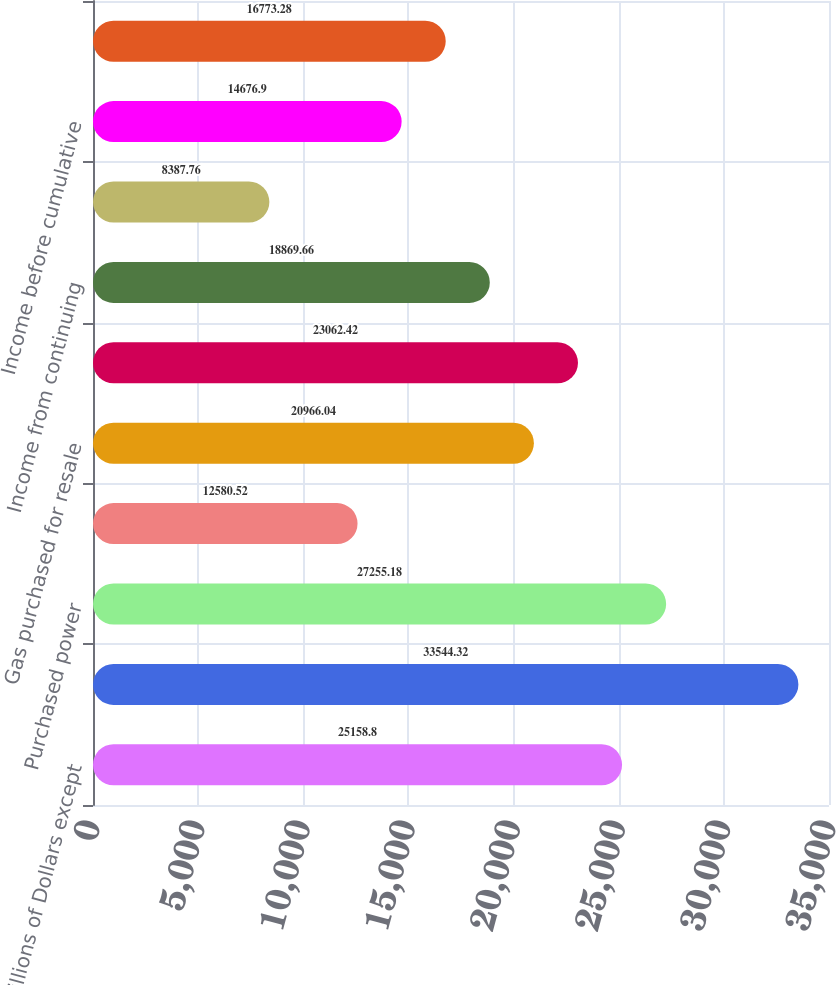<chart> <loc_0><loc_0><loc_500><loc_500><bar_chart><fcel>(Millions of Dollars except<fcel>Operating revenues<fcel>Purchased power<fcel>Fuel<fcel>Gas purchased for resale<fcel>Operating income<fcel>Income from continuing<fcel>Loss from discontinued<fcel>Income before cumulative<fcel>Net income<nl><fcel>25158.8<fcel>33544.3<fcel>27255.2<fcel>12580.5<fcel>20966<fcel>23062.4<fcel>18869.7<fcel>8387.76<fcel>14676.9<fcel>16773.3<nl></chart> 